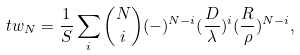Convert formula to latex. <formula><loc_0><loc_0><loc_500><loc_500>\ t w _ { N } = \frac { 1 } { S } \sum _ { i } { N \choose i } ( - ) ^ { N - i } ( \frac { D } { \lambda } ) ^ { i } ( \frac { R } { \rho } ) ^ { N - i } ,</formula> 